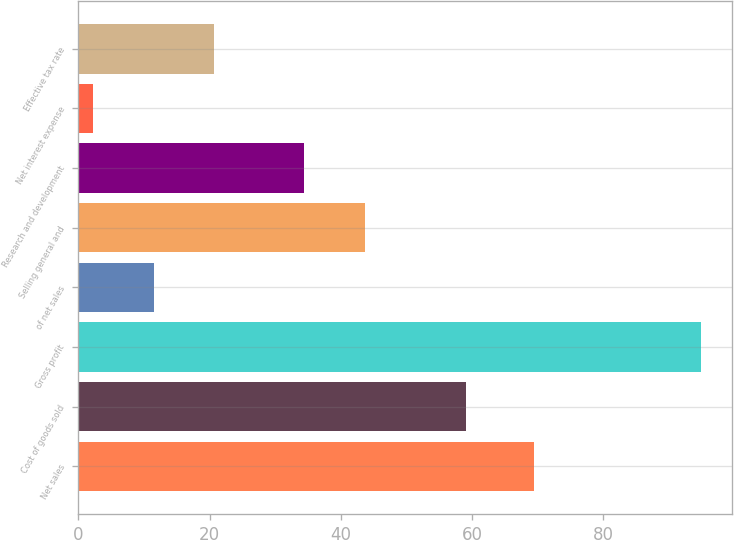<chart> <loc_0><loc_0><loc_500><loc_500><bar_chart><fcel>Net sales<fcel>Cost of goods sold<fcel>Gross profit<fcel>of net sales<fcel>Selling general and<fcel>Research and development<fcel>Net interest expense<fcel>Effective tax rate<nl><fcel>69.4<fcel>59.1<fcel>94.8<fcel>11.46<fcel>43.66<fcel>34.4<fcel>2.2<fcel>20.72<nl></chart> 